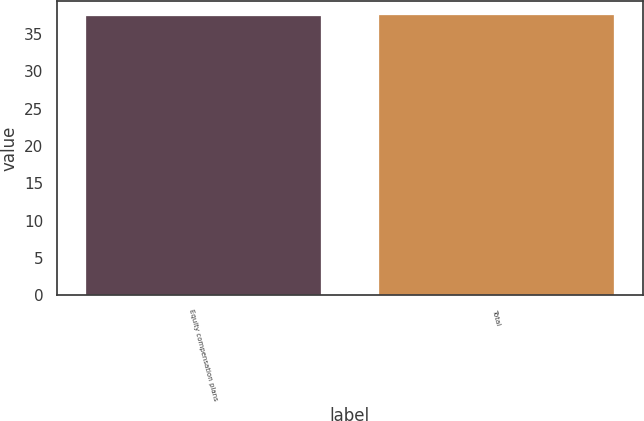<chart> <loc_0><loc_0><loc_500><loc_500><bar_chart><fcel>Equity compensation plans<fcel>Total<nl><fcel>37.49<fcel>37.59<nl></chart> 